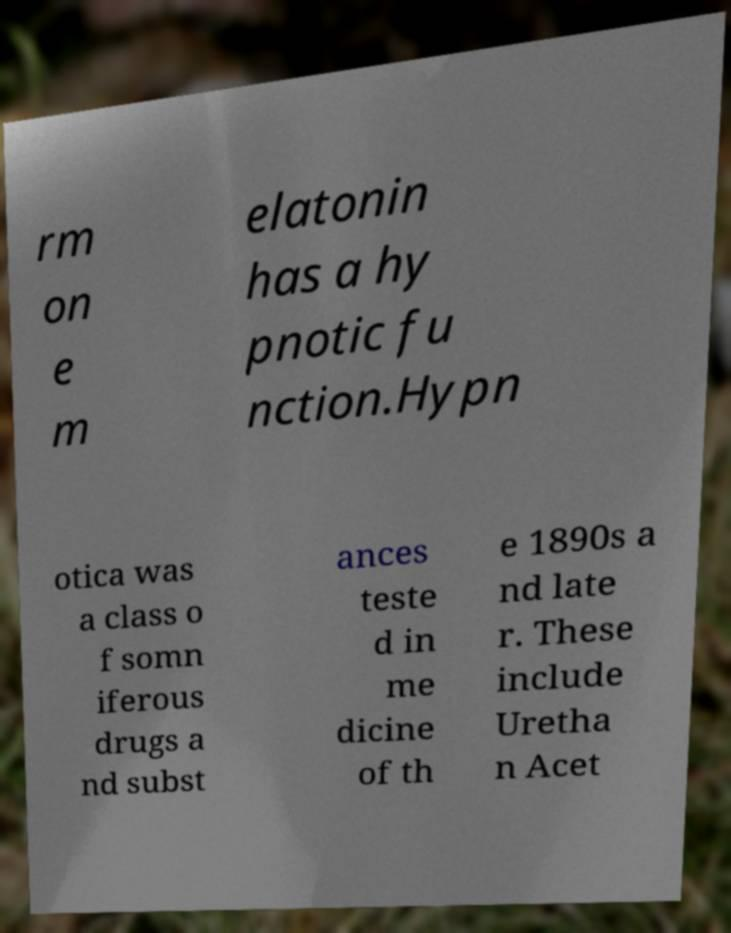I need the written content from this picture converted into text. Can you do that? rm on e m elatonin has a hy pnotic fu nction.Hypn otica was a class o f somn iferous drugs a nd subst ances teste d in me dicine of th e 1890s a nd late r. These include Uretha n Acet 